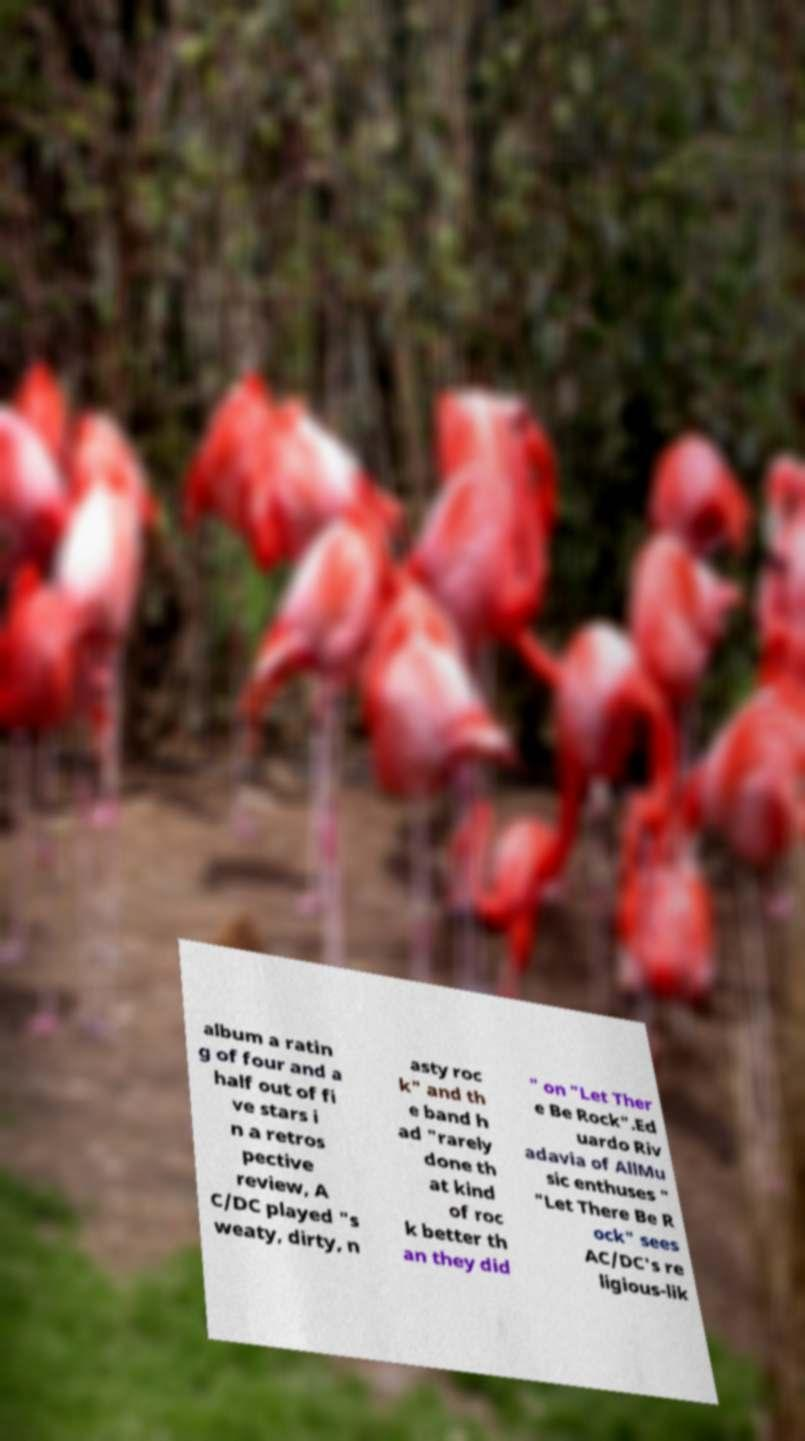What messages or text are displayed in this image? I need them in a readable, typed format. album a ratin g of four and a half out of fi ve stars i n a retros pective review, A C/DC played "s weaty, dirty, n asty roc k" and th e band h ad "rarely done th at kind of roc k better th an they did " on "Let Ther e Be Rock".Ed uardo Riv adavia of AllMu sic enthuses " "Let There Be R ock" sees AC/DC's re ligious-lik 